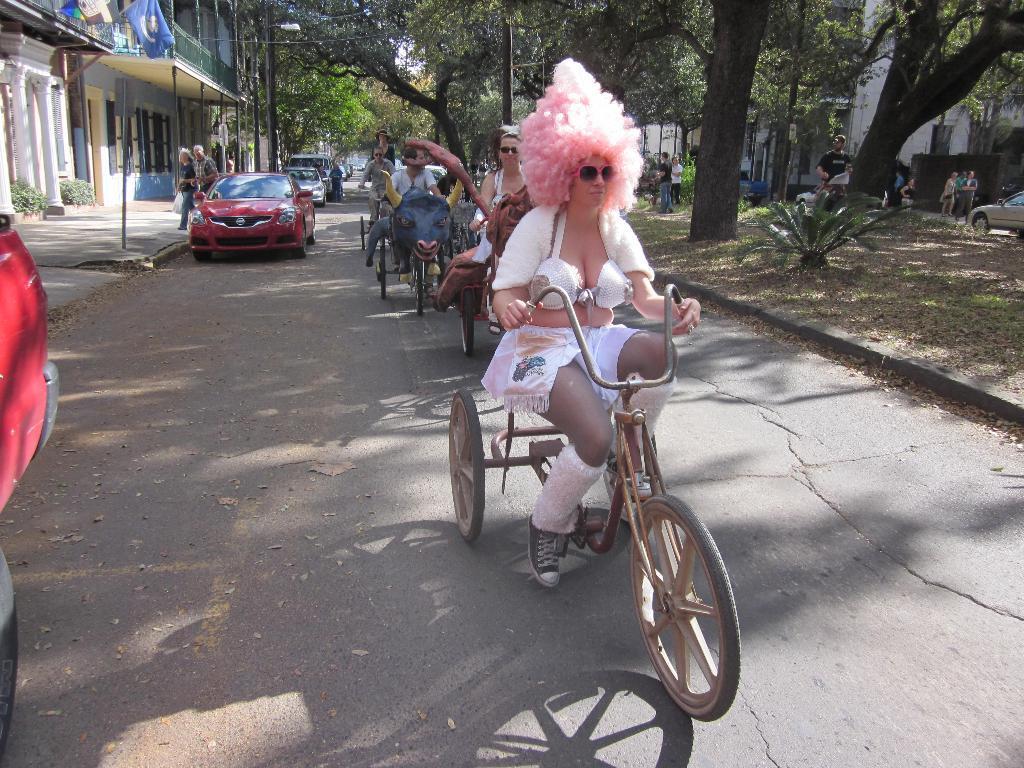How would you summarize this image in a sentence or two? On the left side of the image we can see cars, two persons are walking on the footpath and buildings are there. In the middle of the image we can see some people are riding bicycles and one bicycle is having an animal face on it. On the right side of the image we can see some persons, grass and trees. 